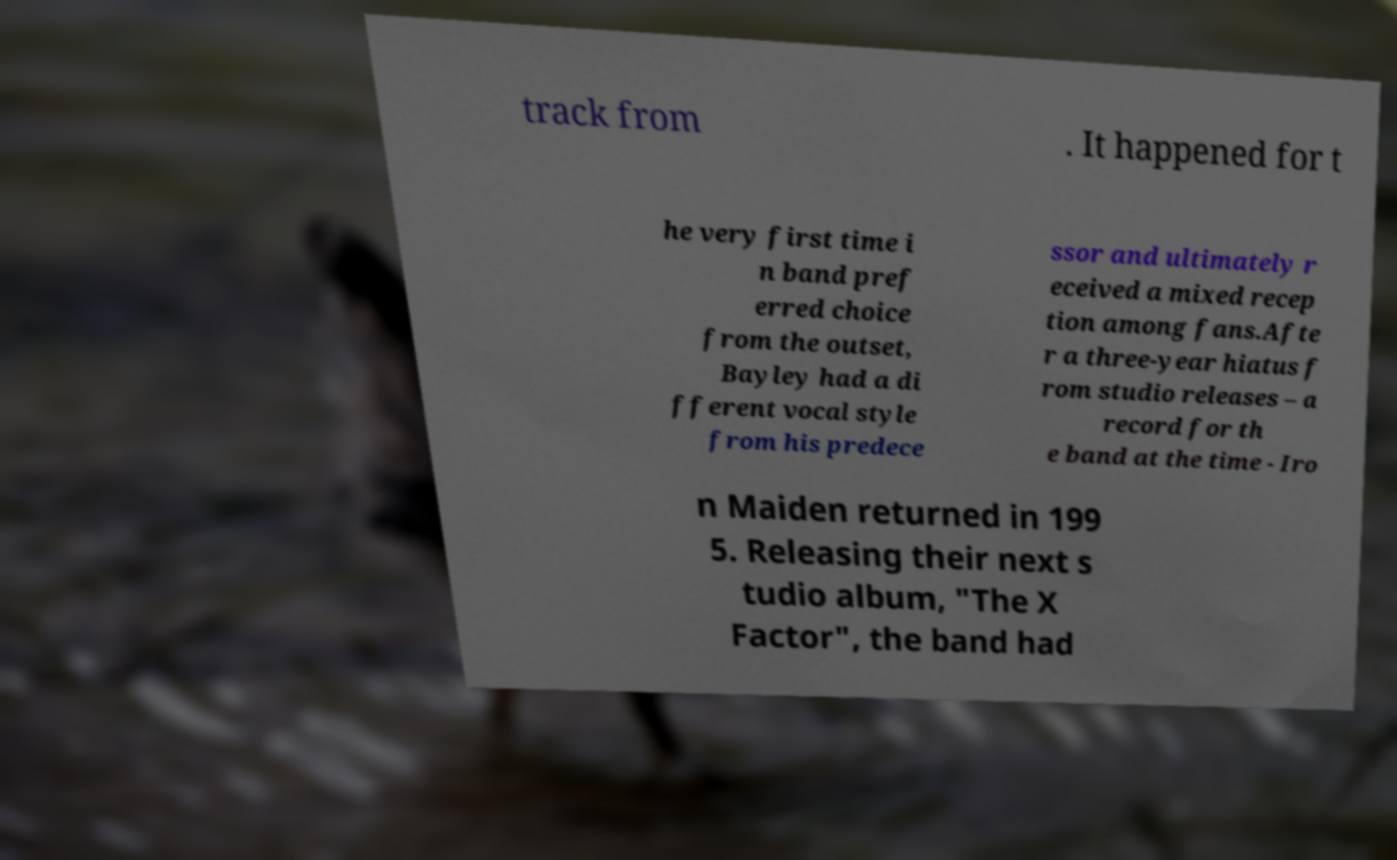Please read and relay the text visible in this image. What does it say? track from . It happened for t he very first time i n band pref erred choice from the outset, Bayley had a di fferent vocal style from his predece ssor and ultimately r eceived a mixed recep tion among fans.Afte r a three-year hiatus f rom studio releases – a record for th e band at the time - Iro n Maiden returned in 199 5. Releasing their next s tudio album, "The X Factor", the band had 